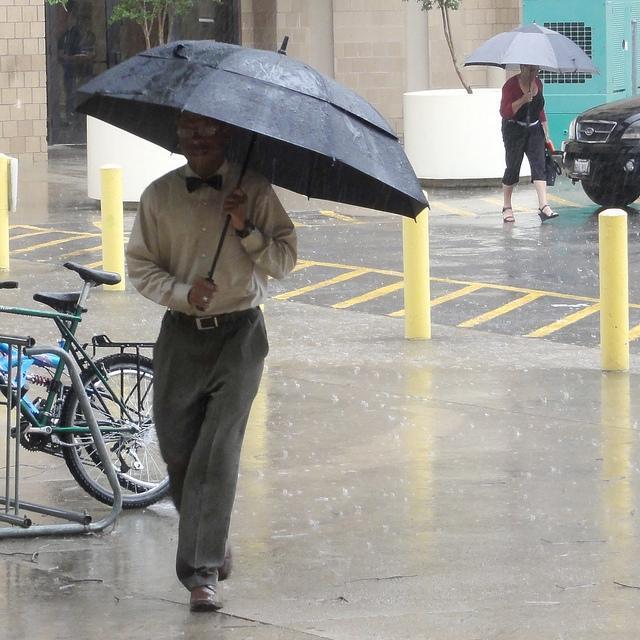How many umbrellas in the photo?
Give a very brief answer. 2. How many umbrella are open?
Give a very brief answer. 2. How many people are in the picture?
Give a very brief answer. 2. How many bicycles are there?
Give a very brief answer. 2. How many umbrellas are in the photo?
Give a very brief answer. 2. 